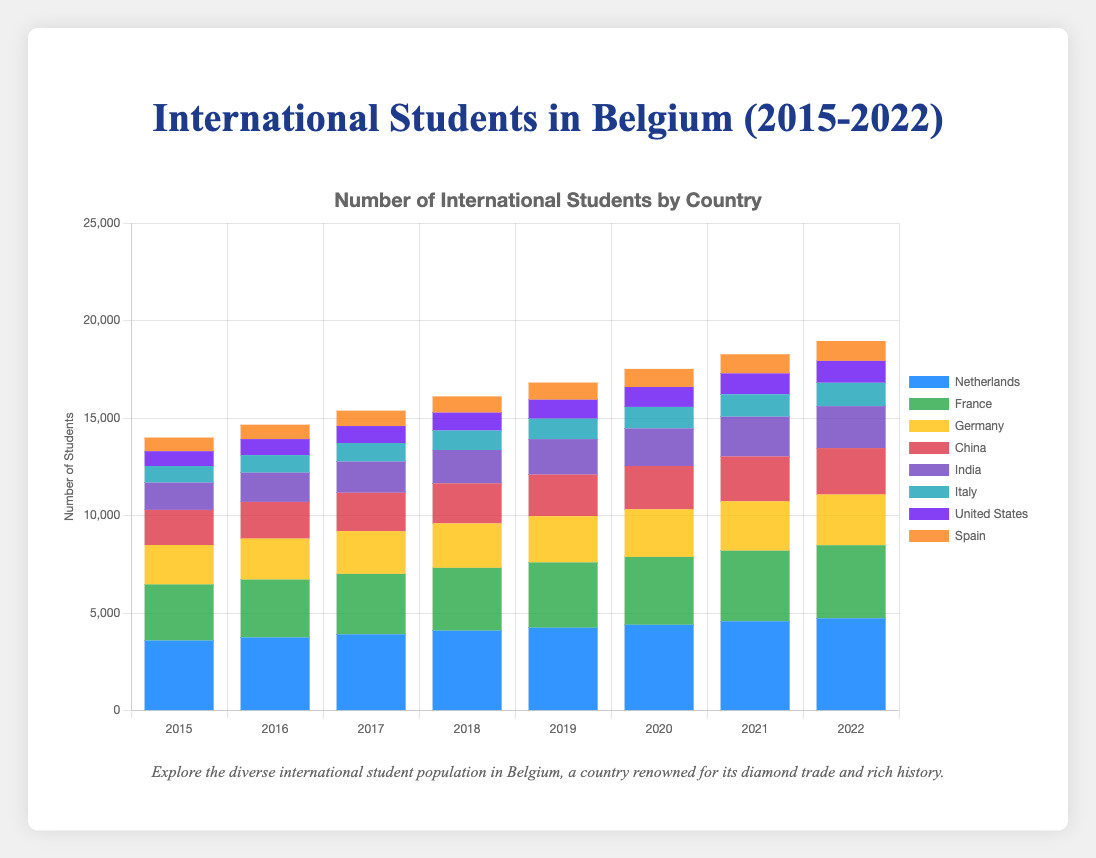Which country had the most significant increase in the number of students between 2015 and 2022? To find the country with the most significant increase, we subtract the 2015 value from the 2022 value for each country. The increases are: Netherlands (1140), France (870), Germany (580), China (580), India (750), Italy (350), United States (360), Spain (320). The largest increase is for the Netherlands.
Answer: Netherlands How many total international students were there in Belgium in 2022? To find the total number of international students in 2022, sum up the students from all countries in 2022: Netherlands (4730), France (3750), Germany (2600), China (2380), India (2150), Italy (1200), United States (1120), Spain (1020). The total is 4730 + 3750 + 2600 + 2380 + 2150 + 1200 + 1120 + 1020 = 18950.
Answer: 18950 Which two countries had the closest number of students in 2021? To find the closest numbers, compare the 2021 student populations: Netherlands (4580), France (3620), Germany (2530), China (2300), India (2040), Italy (1150), United States (1070), Spain (980). The closest numbers are United States (1070) and Italy (1150) with a difference of 80 students.
Answer: United States and Italy What is the average number of students from China between 2015 and 2022? First, sum the students from China for each year: 1800 + 1880 + 1970 + 2050 + 2130 + 2220 + 2300 + 2380 = 16730. There are 8 years, so the average is 16730 / 8 = 2091.25.
Answer: 2091.25 Which year saw the largest increase in the total number of students from all countries? Calculate the total number of students for each year and then find the year-to-year difference: 2015 (13400), 2016 (13660), 2017 (14020), 2018 (14510), 2019 (14900), 2020 (15320), 2021 (15800), 2022 (16350). The differences are: 2016 (260), 2017 (360), 2018 (490), 2019 (390), 2020 (420), 2021 (480), 2022 (550). The largest increase was from 2021 to 2022 with 550 students.
Answer: 2022 How did the number of students from India change from 2017 to 2019? The number of students from India in 2017 was 1600 and in 2019 was 1820. The change is 1820 - 1600 = 220.
Answer: 220 Which country had the smallest student population in 2015? Compare the student populations in 2015: Netherlands (3590), France (2880), Germany (2020), China (1800), India (1400), Italy (850), United States (760), Spain (700). The smallest population is from Spain.
Answer: Spain What is the trend for the number of students from Italy from 2015 to 2022? The number of students from Italy increases every year from 2015 (850) to 2022 (1200). This shows a steady upward trend.
Answer: Steady upward trend How did the student population from the Netherlands change relative to Germany from 2015 to 2022? Subtract the 2015 numbers from the 2022 numbers for both countries: Netherlands increased by 4730 - 3590 = 1140, Germany increased by 2600 - 2020 = 580. The student population from the Netherlands increased more than that from Germany by 1140 - 580 = 560.
Answer: Increased 560 more than Germany 